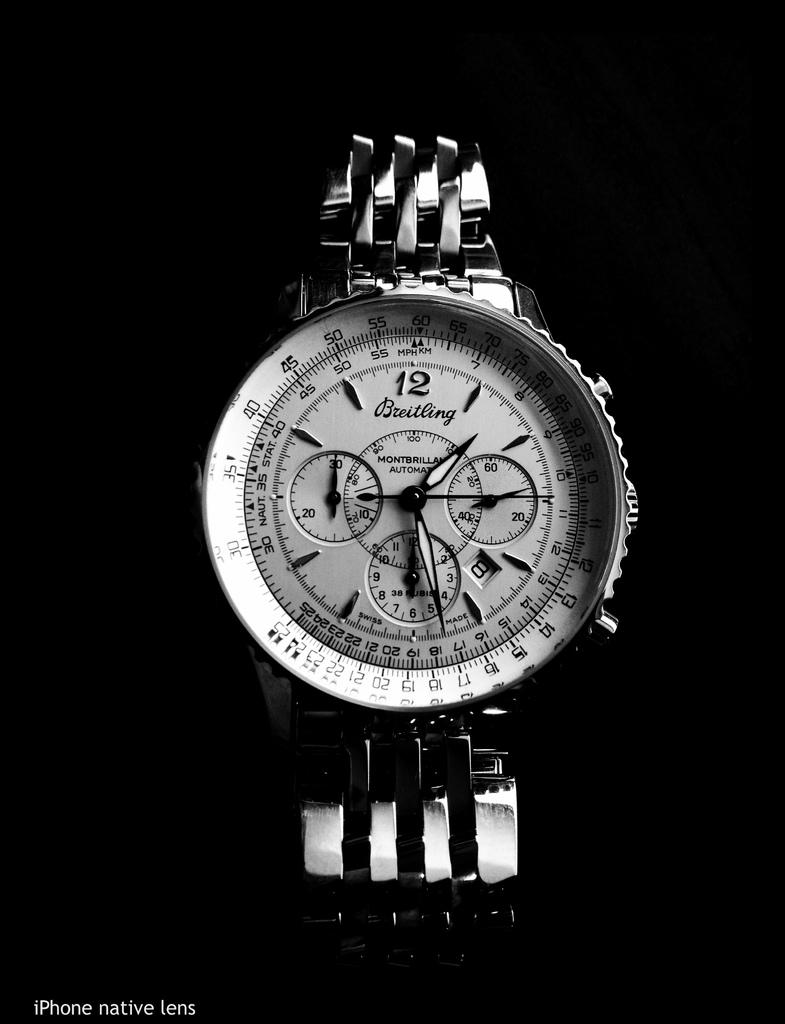<image>
Create a compact narrative representing the image presented. A white watch says "Breitling" on the face. 